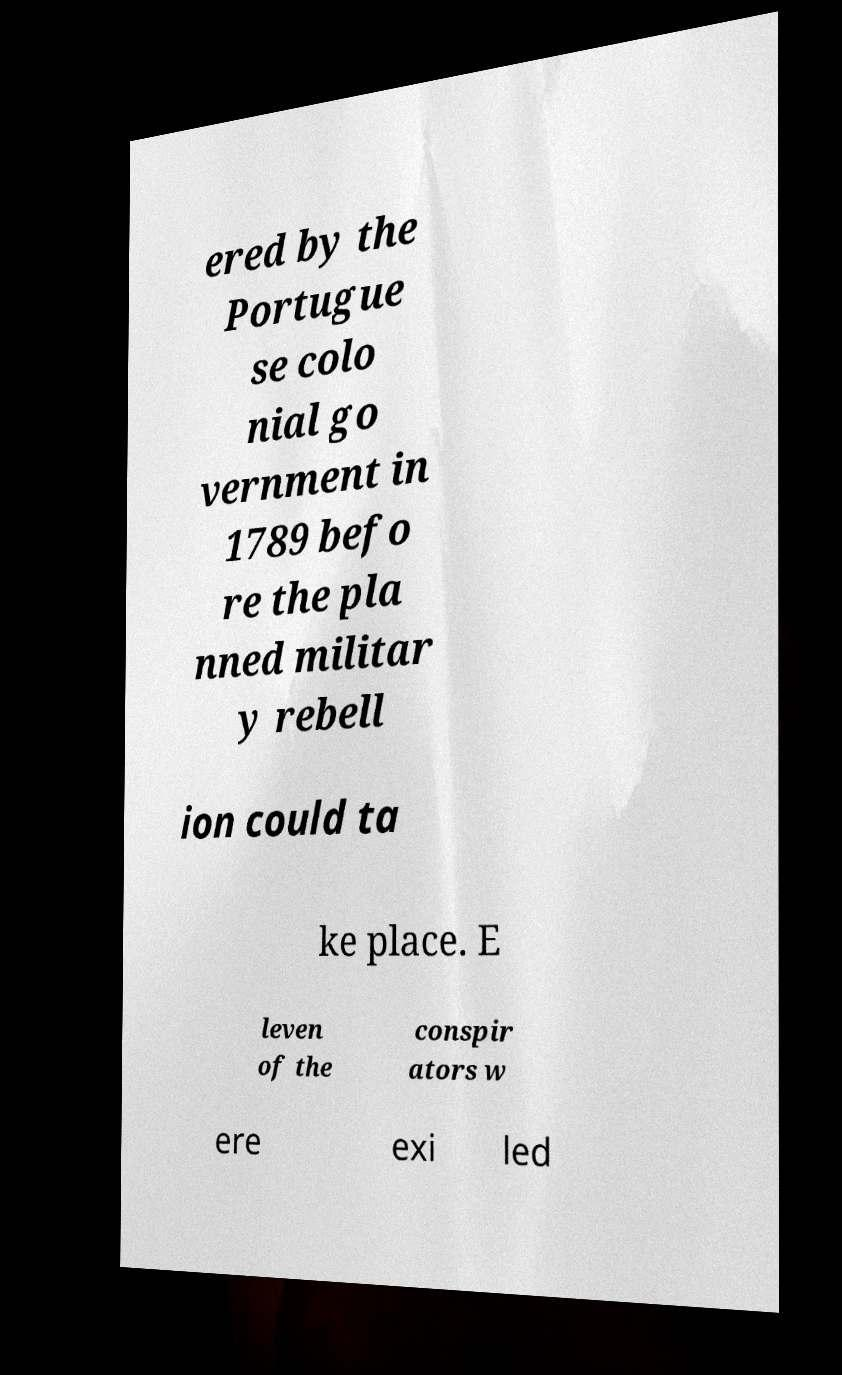Could you extract and type out the text from this image? ered by the Portugue se colo nial go vernment in 1789 befo re the pla nned militar y rebell ion could ta ke place. E leven of the conspir ators w ere exi led 